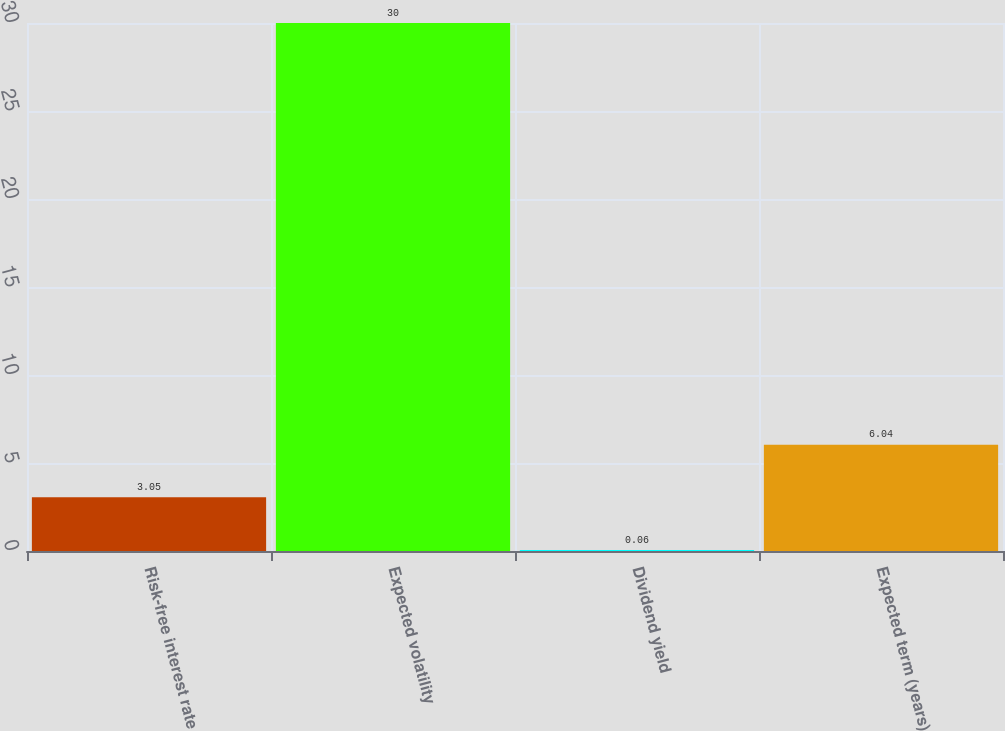<chart> <loc_0><loc_0><loc_500><loc_500><bar_chart><fcel>Risk-free interest rate<fcel>Expected volatility<fcel>Dividend yield<fcel>Expected term (years)<nl><fcel>3.05<fcel>30<fcel>0.06<fcel>6.04<nl></chart> 